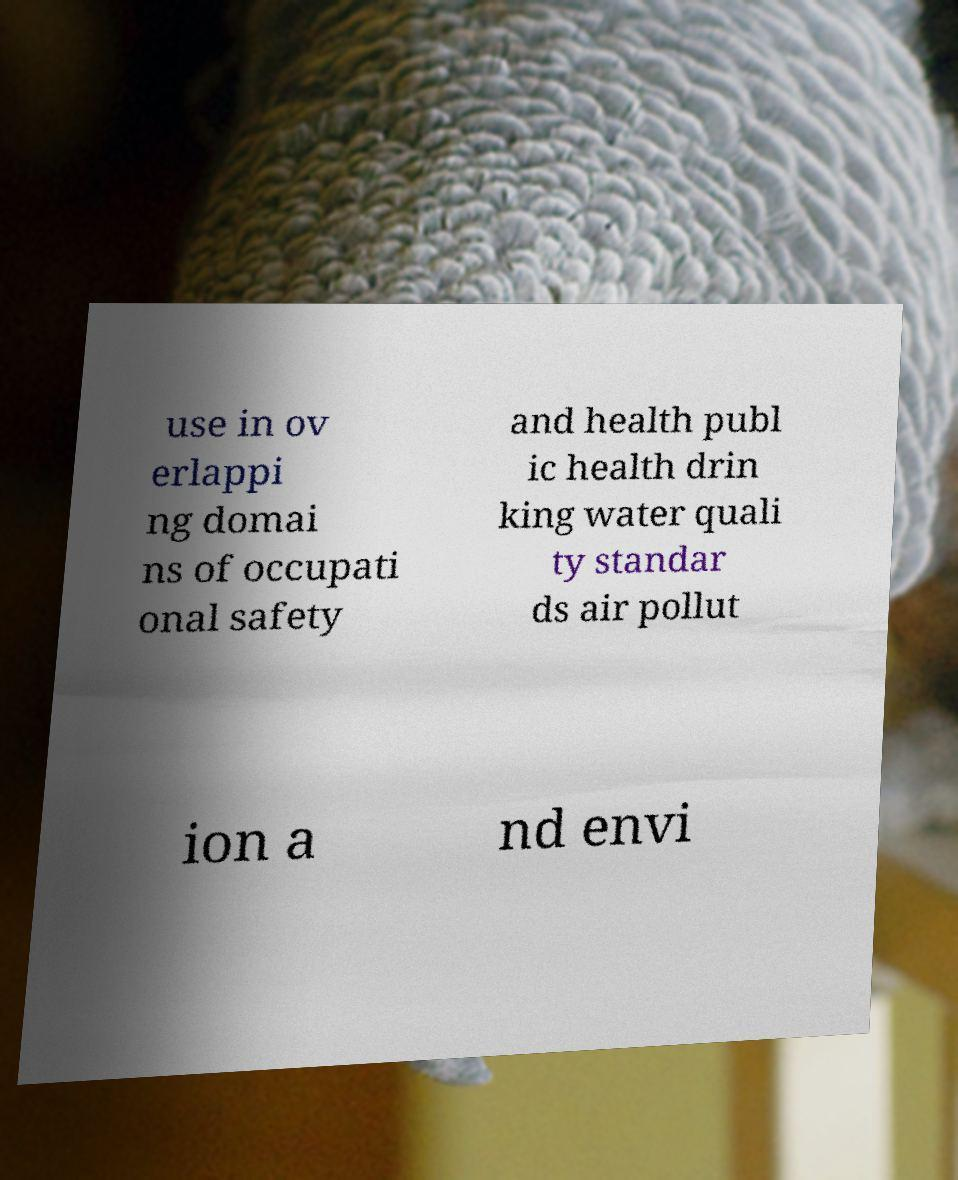Could you assist in decoding the text presented in this image and type it out clearly? use in ov erlappi ng domai ns of occupati onal safety and health publ ic health drin king water quali ty standar ds air pollut ion a nd envi 